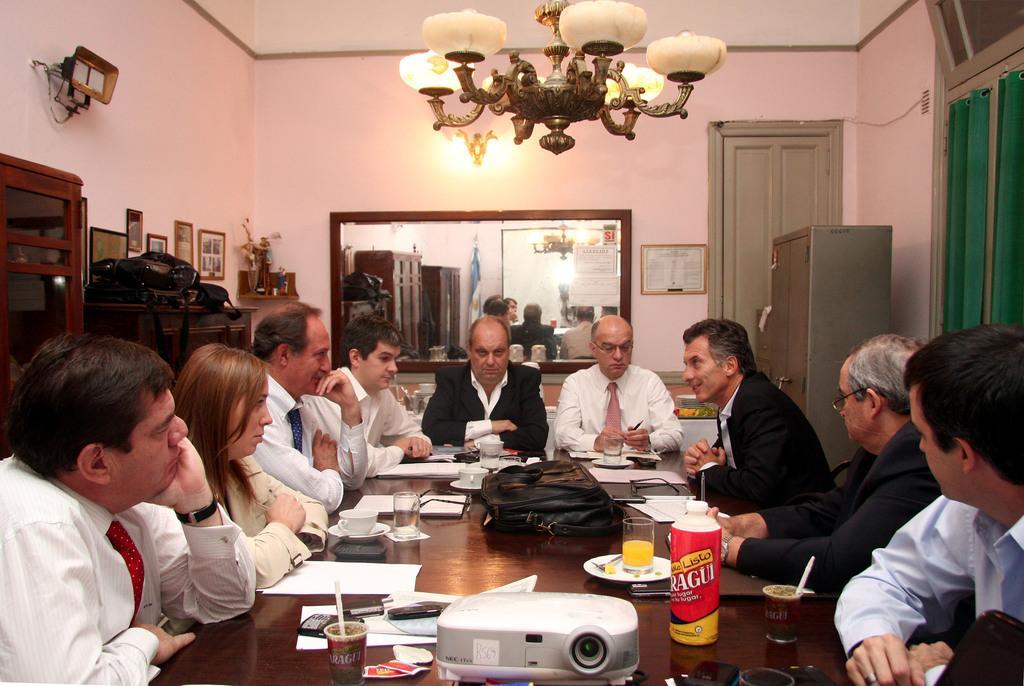Could you give a brief overview of what you see in this image? In the image we can see there are lot of people who are sitting on chair and on table there is projector and bottle. 